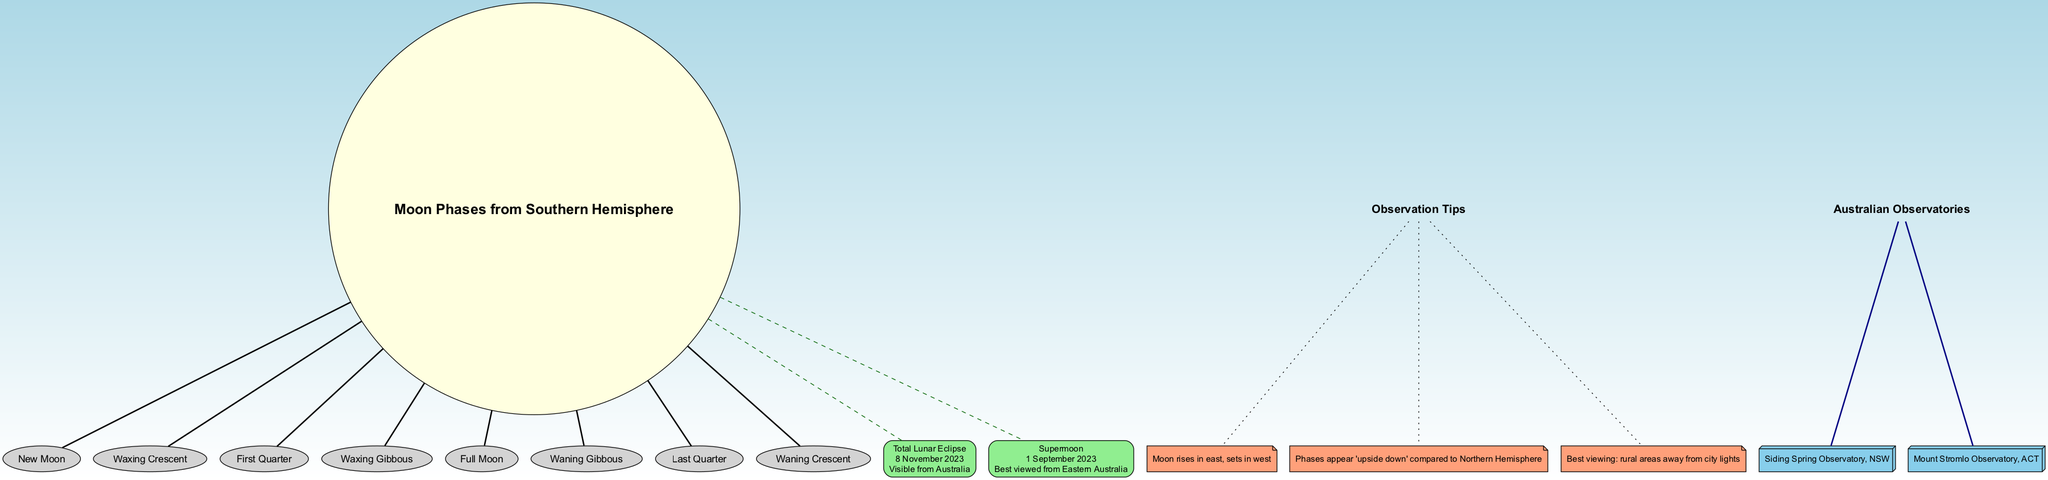What are the moon phases noted in the diagram? The diagram lists the moon phases in sequence around the center node named "Moon Phases from Southern Hemisphere." They are: New Moon, Waxing Crescent, First Quarter, Waxing Gibbous, Full Moon, Waning Gibbous, Last Quarter, and Waning Crescent.
Answer: New Moon, Waxing Crescent, First Quarter, Waxing Gibbous, Full Moon, Waning Gibbous, Last Quarter, Waning Crescent What is the date of the Total Lunar Eclipse? The key events section of the diagram specifies that the date of the Total Lunar Eclipse is noted as 8 November 2023.
Answer: 8 November 2023 Which moon phase appears after First Quarter? By following the sequence of moon phases around the central node, directly after First Quarter, Waxing Gibbous is noted as the next phase in the cycle.
Answer: Waxing Gibbous What is the visibility status of the upcoming Supermoon event? According to the key events section, the visibility status for the Supermoon on 1 September 2023 is defined as "Best viewed from Eastern Australia".
Answer: Best viewed from Eastern Australia How many observation tips are provided in the diagram? The observation tips are detailed in a specific section of the diagram. There are a total of three distinct tips listed.
Answer: 3 Which Australian observatory is located in New South Wales? The Australian Observatories section specifies two observatories, of which Siding Spring Observatory is indicated as being in New South Wales.
Answer: Siding Spring Observatory What is the general direction in which the Moon rises? The observation tips state that the Moon rises in the east, indicating the common direction in which it appears on the horizon.
Answer: East What happens to the appearance of Moon phases when viewed from the Southern Hemisphere? From the observation tips section, it is noted that the Moon phases appear 'upside down' when compared to their appearance in the Northern Hemisphere.
Answer: Upside down 